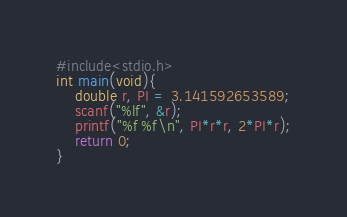<code> <loc_0><loc_0><loc_500><loc_500><_C_>#include<stdio.h>
int main(void){
    double r, PI = 3.141592653589;
    scanf("%lf", &r);
    printf("%f %f\n", PI*r*r, 2*PI*r);
    return 0;
}

</code> 